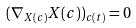Convert formula to latex. <formula><loc_0><loc_0><loc_500><loc_500>( \nabla _ { X ( { c } ) } X ( { c } ) ) _ { c ( t ) } = 0</formula> 